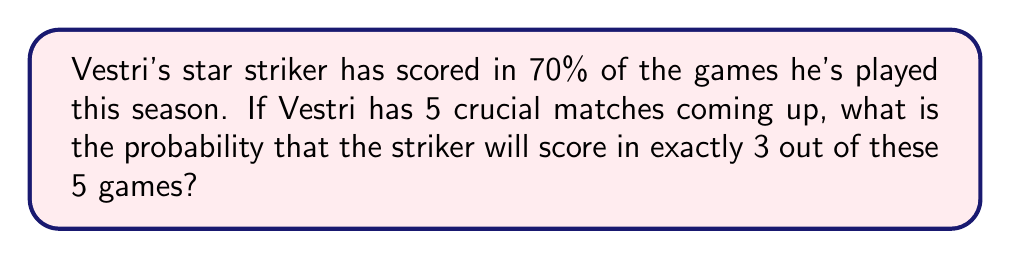Solve this math problem. To solve this problem, we'll use the binomial probability distribution, which is appropriate for a fixed number of independent trials with two possible outcomes (success or failure).

Let's define our variables:
$p = 0.7$ (probability of scoring in a single game)
$q = 1 - p = 0.3$ (probability of not scoring in a single game)
$n = 5$ (number of games)
$k = 3$ (number of successful outcomes we're interested in)

The binomial probability formula is:

$$P(X = k) = \binom{n}{k} p^k q^{n-k}$$

Where $\binom{n}{k}$ is the binomial coefficient, calculated as:

$$\binom{n}{k} = \frac{n!}{k!(n-k)!}$$

Step 1: Calculate the binomial coefficient
$$\binom{5}{3} = \frac{5!}{3!(5-3)!} = \frac{5 \cdot 4 \cdot 3 \cdot 2 \cdot 1}{(3 \cdot 2 \cdot 1)(2 \cdot 1)} = 10$$

Step 2: Apply the binomial probability formula
$$P(X = 3) = 10 \cdot (0.7)^3 \cdot (0.3)^{5-3}$$
$$= 10 \cdot (0.7)^3 \cdot (0.3)^2$$
$$= 10 \cdot 0.343 \cdot 0.09$$
$$= 0.3087$$

Step 3: Convert to percentage
$0.3087 \cdot 100\% = 30.87\%$

Therefore, the probability that Vestri's star striker will score in exactly 3 out of the 5 upcoming crucial matches is approximately 30.87%.
Answer: 30.87% 